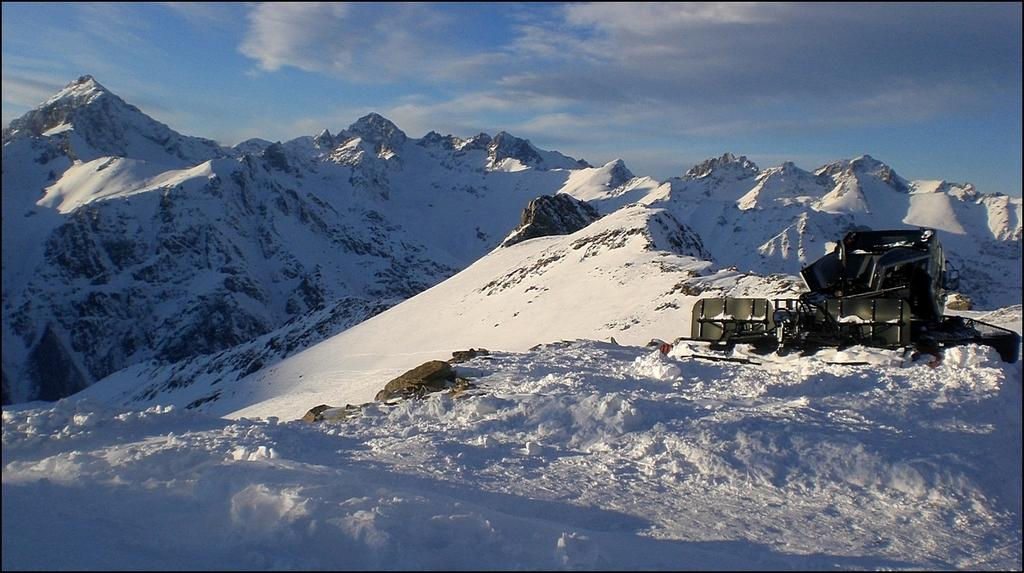What is the main subject of the image? The main subject of the image is an ice mower. Where is the ice mower located? The ice mower is on snowy mountains. What can be seen in the sky at the top of the image? There are clouds in the sky at the top of the image. What type of tin is being used by the lawyer in the image? There is no tin or lawyer present in the image; it features an ice mower on snowy mountains with clouds in the sky. What is the belief of the ice mower in the image? The ice mower is an inanimate object and does not have beliefs. 